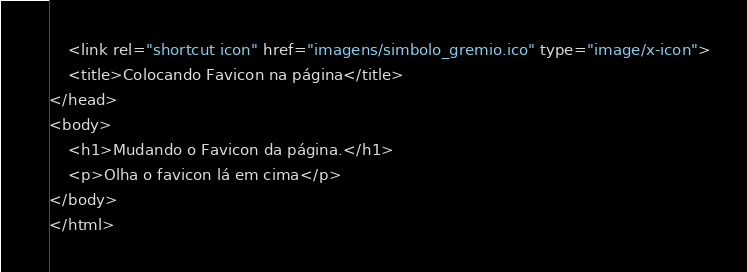<code> <loc_0><loc_0><loc_500><loc_500><_HTML_>    <link rel="shortcut icon" href="imagens/simbolo_gremio.ico" type="image/x-icon">
    <title>Colocando Favicon na página</title>
</head>
<body>
    <h1>Mudando o Favicon da página.</h1>
    <p>Olha o favicon lá em cima</p>
</body>
</html></code> 